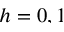<formula> <loc_0><loc_0><loc_500><loc_500>h = 0 , 1</formula> 